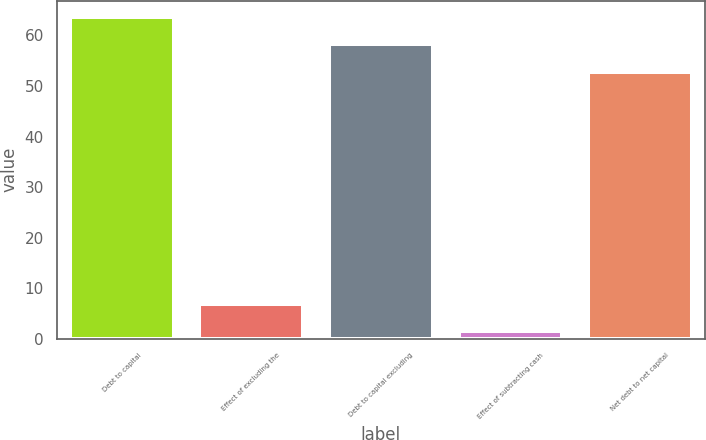Convert chart to OTSL. <chart><loc_0><loc_0><loc_500><loc_500><bar_chart><fcel>Debt to capital<fcel>Effect of excluding the<fcel>Debt to capital excluding<fcel>Effect of subtracting cash<fcel>Net debt to net capital<nl><fcel>63.68<fcel>6.94<fcel>58.24<fcel>1.5<fcel>52.8<nl></chart> 